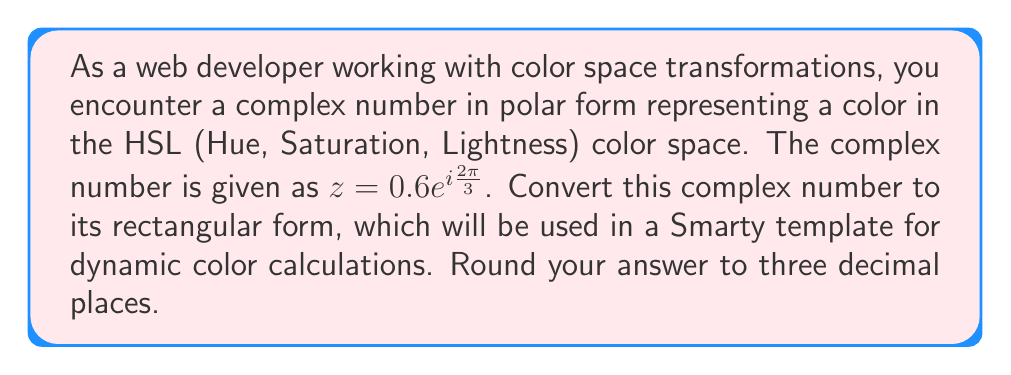Give your solution to this math problem. To convert a complex number from polar form to rectangular form, we use the following formula:

$$z = re^{i\theta} = r(\cos\theta + i\sin\theta)$$

Where:
$r$ is the magnitude (modulus)
$\theta$ is the argument (angle)

Given:
$z = 0.6e^{i\frac{2\pi}{3}}$

Step 1: Identify $r$ and $\theta$
$r = 0.6$
$\theta = \frac{2\pi}{3}$

Step 2: Apply the formula
$$z = 0.6(\cos(\frac{2\pi}{3}) + i\sin(\frac{2\pi}{3}))$$

Step 3: Calculate $\cos(\frac{2\pi}{3})$ and $\sin(\frac{2\pi}{3})$
$\cos(\frac{2\pi}{3}) = -0.5$
$\sin(\frac{2\pi}{3}) = \frac{\sqrt{3}}{2}$

Step 4: Substitute the values
$$z = 0.6(-0.5 + i\frac{\sqrt{3}}{2})$$

Step 5: Simplify
$$z = -0.3 + i0.6\frac{\sqrt{3}}{2}$$
$$z = -0.3 + i0.3\sqrt{3}$$

Step 6: Round to three decimal places
Real part: $-0.300$
Imaginary part: $0.520i$ (since $0.3\sqrt{3} \approx 0.520$)

Therefore, the rectangular form of the complex number is:
$$z \approx -0.300 + 0.520i$$
Answer: $z \approx -0.300 + 0.520i$ 